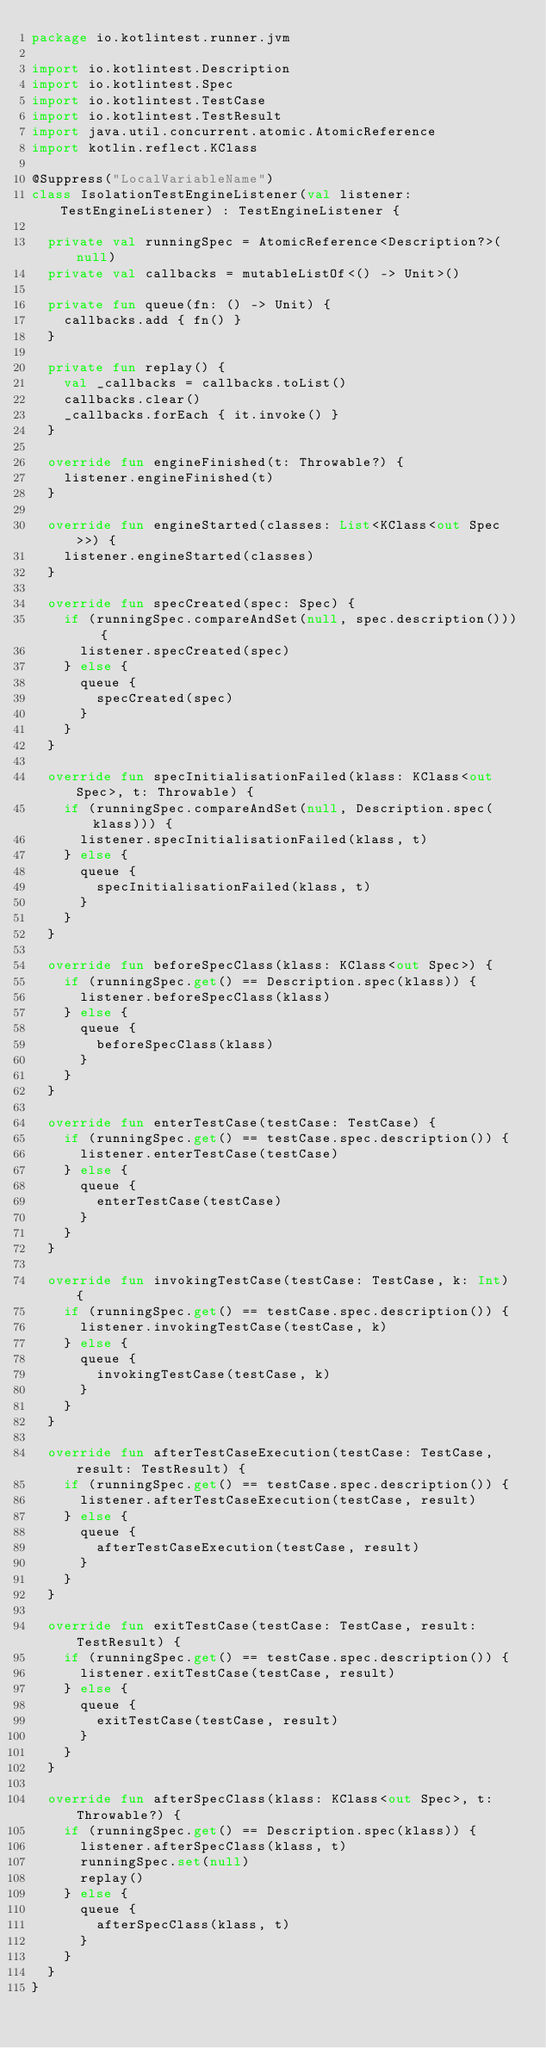<code> <loc_0><loc_0><loc_500><loc_500><_Kotlin_>package io.kotlintest.runner.jvm

import io.kotlintest.Description
import io.kotlintest.Spec
import io.kotlintest.TestCase
import io.kotlintest.TestResult
import java.util.concurrent.atomic.AtomicReference
import kotlin.reflect.KClass

@Suppress("LocalVariableName")
class IsolationTestEngineListener(val listener: TestEngineListener) : TestEngineListener {

  private val runningSpec = AtomicReference<Description?>(null)
  private val callbacks = mutableListOf<() -> Unit>()

  private fun queue(fn: () -> Unit) {
    callbacks.add { fn() }
  }

  private fun replay() {
    val _callbacks = callbacks.toList()
    callbacks.clear()
    _callbacks.forEach { it.invoke() }
  }

  override fun engineFinished(t: Throwable?) {
    listener.engineFinished(t)
  }

  override fun engineStarted(classes: List<KClass<out Spec>>) {
    listener.engineStarted(classes)
  }

  override fun specCreated(spec: Spec) {
    if (runningSpec.compareAndSet(null, spec.description())) {
      listener.specCreated(spec)
    } else {
      queue {
        specCreated(spec)
      }
    }
  }

  override fun specInitialisationFailed(klass: KClass<out Spec>, t: Throwable) {
    if (runningSpec.compareAndSet(null, Description.spec(klass))) {
      listener.specInitialisationFailed(klass, t)
    } else {
      queue {
        specInitialisationFailed(klass, t)
      }
    }
  }

  override fun beforeSpecClass(klass: KClass<out Spec>) {
    if (runningSpec.get() == Description.spec(klass)) {
      listener.beforeSpecClass(klass)
    } else {
      queue {
        beforeSpecClass(klass)
      }
    }
  }

  override fun enterTestCase(testCase: TestCase) {
    if (runningSpec.get() == testCase.spec.description()) {
      listener.enterTestCase(testCase)
    } else {
      queue {
        enterTestCase(testCase)
      }
    }
  }

  override fun invokingTestCase(testCase: TestCase, k: Int) {
    if (runningSpec.get() == testCase.spec.description()) {
      listener.invokingTestCase(testCase, k)
    } else {
      queue {
        invokingTestCase(testCase, k)
      }
    }
  }

  override fun afterTestCaseExecution(testCase: TestCase, result: TestResult) {
    if (runningSpec.get() == testCase.spec.description()) {
      listener.afterTestCaseExecution(testCase, result)
    } else {
      queue {
        afterTestCaseExecution(testCase, result)
      }
    }
  }

  override fun exitTestCase(testCase: TestCase, result: TestResult) {
    if (runningSpec.get() == testCase.spec.description()) {
      listener.exitTestCase(testCase, result)
    } else {
      queue {
        exitTestCase(testCase, result)
      }
    }
  }

  override fun afterSpecClass(klass: KClass<out Spec>, t: Throwable?) {
    if (runningSpec.get() == Description.spec(klass)) {
      listener.afterSpecClass(klass, t)
      runningSpec.set(null)
      replay()
    } else {
      queue {
        afterSpecClass(klass, t)
      }
    }
  }
}</code> 